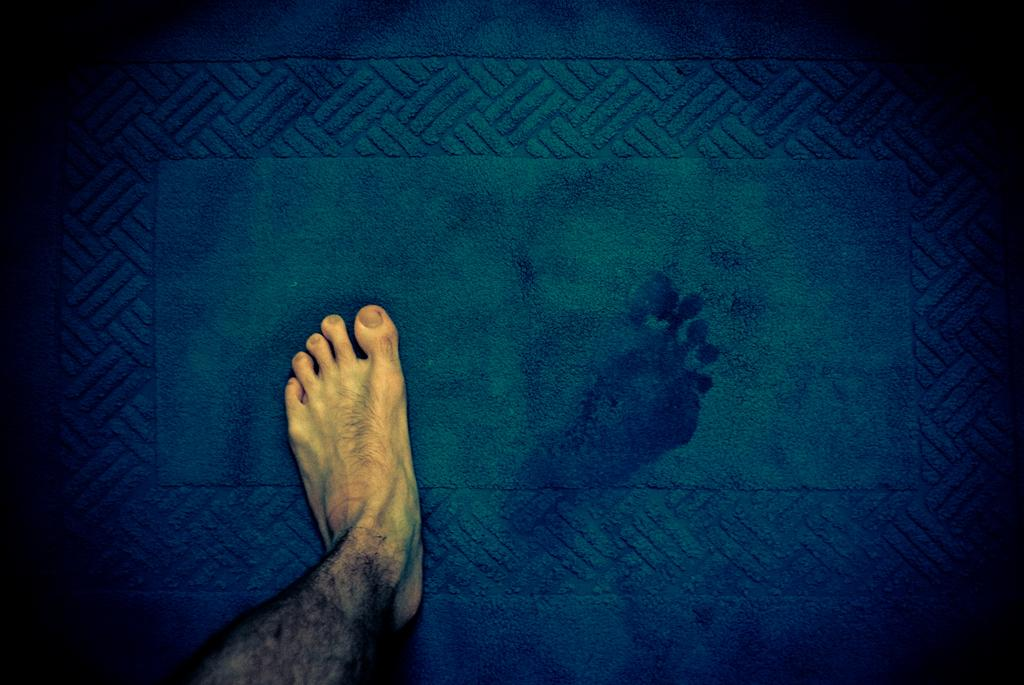What part of a person's body is visible in the image? There is a person's leg in the image. What is the leg resting on? The leg is on a mat. What color is the mat? The mat is blue in color. What type of paste is being used to create the scent in the image? There is no mention of paste or scent in the image; it only features a person's leg on a blue mat. 